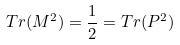<formula> <loc_0><loc_0><loc_500><loc_500>T r ( M ^ { 2 } ) = \frac { 1 } { 2 } = T r ( P ^ { 2 } )</formula> 